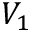Convert formula to latex. <formula><loc_0><loc_0><loc_500><loc_500>V _ { 1 }</formula> 